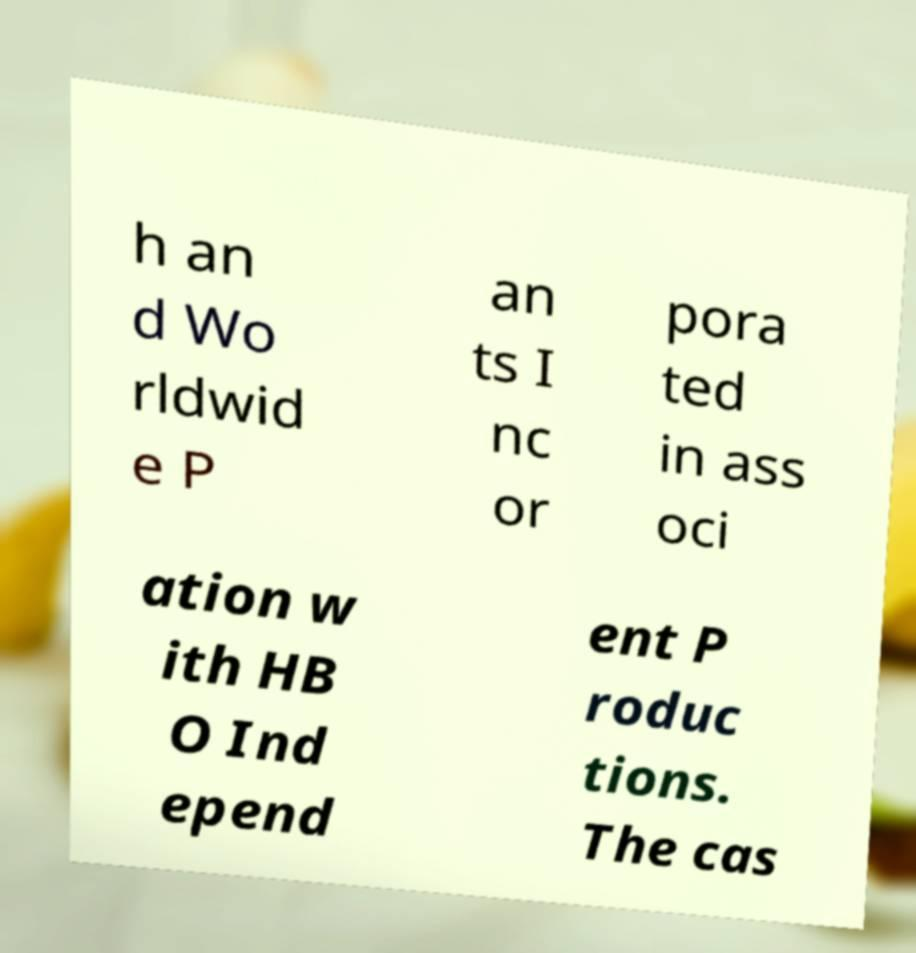For documentation purposes, I need the text within this image transcribed. Could you provide that? h an d Wo rldwid e P an ts I nc or pora ted in ass oci ation w ith HB O Ind epend ent P roduc tions. The cas 